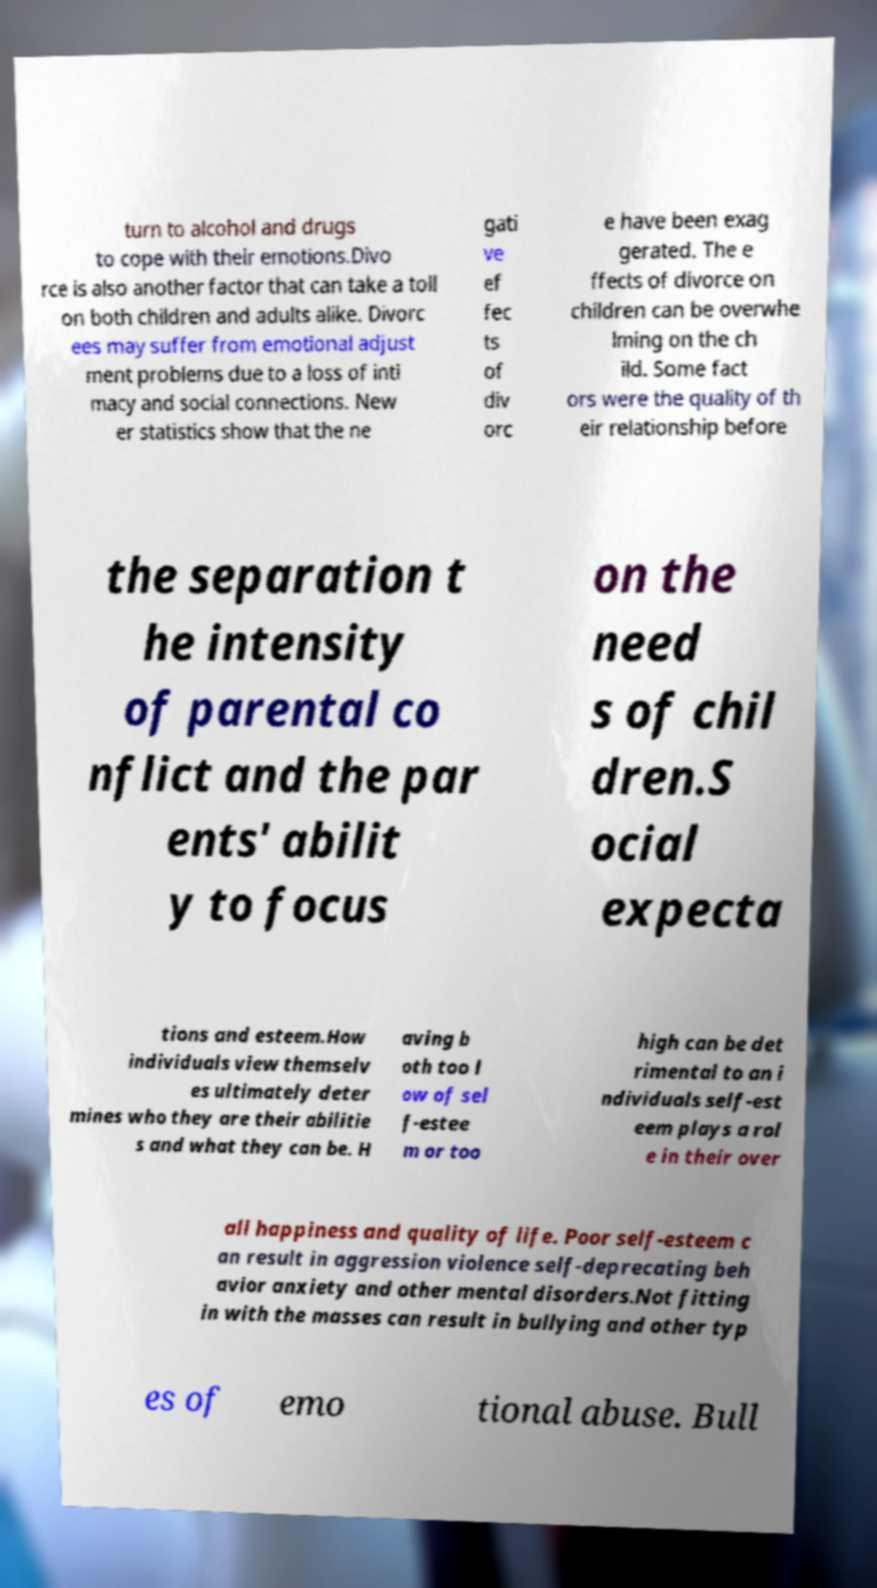Can you read and provide the text displayed in the image?This photo seems to have some interesting text. Can you extract and type it out for me? turn to alcohol and drugs to cope with their emotions.Divo rce is also another factor that can take a toll on both children and adults alike. Divorc ees may suffer from emotional adjust ment problems due to a loss of inti macy and social connections. New er statistics show that the ne gati ve ef fec ts of div orc e have been exag gerated. The e ffects of divorce on children can be overwhe lming on the ch ild. Some fact ors were the quality of th eir relationship before the separation t he intensity of parental co nflict and the par ents' abilit y to focus on the need s of chil dren.S ocial expecta tions and esteem.How individuals view themselv es ultimately deter mines who they are their abilitie s and what they can be. H aving b oth too l ow of sel f-estee m or too high can be det rimental to an i ndividuals self-est eem plays a rol e in their over all happiness and quality of life. Poor self-esteem c an result in aggression violence self-deprecating beh avior anxiety and other mental disorders.Not fitting in with the masses can result in bullying and other typ es of emo tional abuse. Bull 